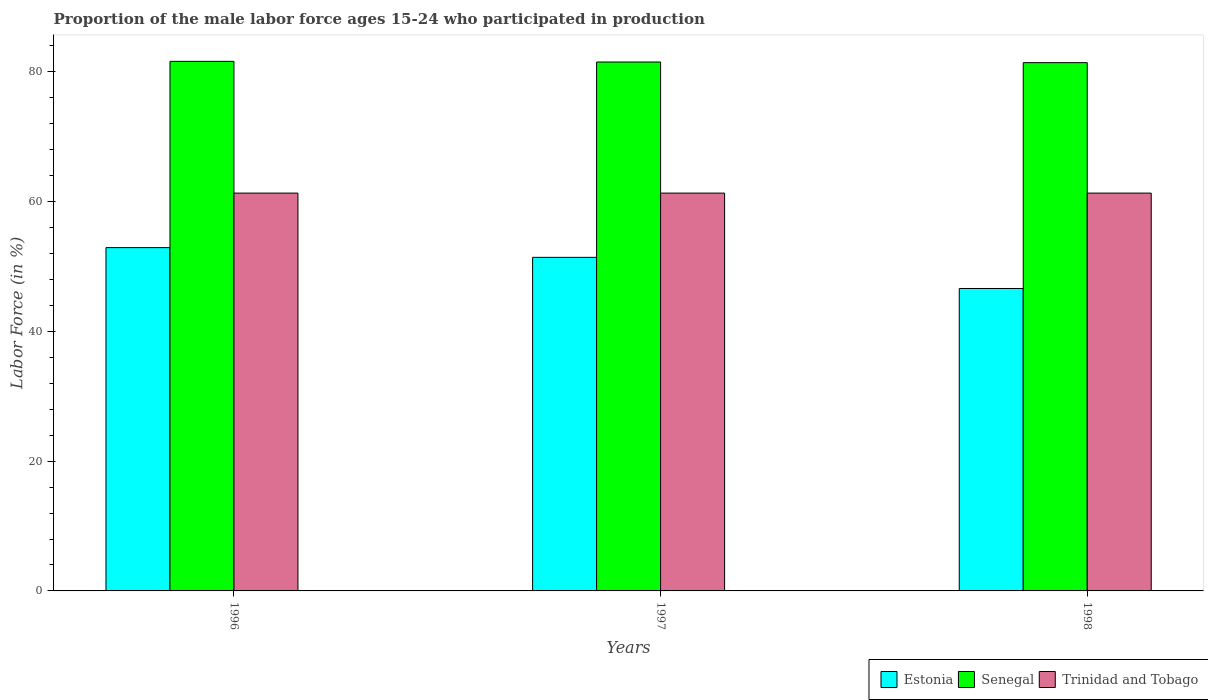How many different coloured bars are there?
Keep it short and to the point. 3. How many groups of bars are there?
Offer a terse response. 3. Are the number of bars on each tick of the X-axis equal?
Your answer should be compact. Yes. How many bars are there on the 3rd tick from the right?
Provide a short and direct response. 3. What is the label of the 1st group of bars from the left?
Your answer should be very brief. 1996. In how many cases, is the number of bars for a given year not equal to the number of legend labels?
Keep it short and to the point. 0. What is the proportion of the male labor force who participated in production in Senegal in 1998?
Keep it short and to the point. 81.4. Across all years, what is the maximum proportion of the male labor force who participated in production in Estonia?
Your response must be concise. 52.9. Across all years, what is the minimum proportion of the male labor force who participated in production in Senegal?
Offer a very short reply. 81.4. In which year was the proportion of the male labor force who participated in production in Trinidad and Tobago maximum?
Keep it short and to the point. 1996. What is the total proportion of the male labor force who participated in production in Trinidad and Tobago in the graph?
Your answer should be compact. 183.9. What is the difference between the proportion of the male labor force who participated in production in Estonia in 1996 and that in 1997?
Keep it short and to the point. 1.5. What is the difference between the proportion of the male labor force who participated in production in Estonia in 1997 and the proportion of the male labor force who participated in production in Senegal in 1996?
Ensure brevity in your answer.  -30.2. What is the average proportion of the male labor force who participated in production in Estonia per year?
Give a very brief answer. 50.3. In the year 1998, what is the difference between the proportion of the male labor force who participated in production in Estonia and proportion of the male labor force who participated in production in Trinidad and Tobago?
Offer a very short reply. -14.7. What is the ratio of the proportion of the male labor force who participated in production in Senegal in 1996 to that in 1998?
Provide a short and direct response. 1. Is the proportion of the male labor force who participated in production in Trinidad and Tobago in 1996 less than that in 1997?
Make the answer very short. No. Is the difference between the proportion of the male labor force who participated in production in Estonia in 1997 and 1998 greater than the difference between the proportion of the male labor force who participated in production in Trinidad and Tobago in 1997 and 1998?
Your answer should be compact. Yes. What is the difference between the highest and the second highest proportion of the male labor force who participated in production in Estonia?
Ensure brevity in your answer.  1.5. What is the difference between the highest and the lowest proportion of the male labor force who participated in production in Trinidad and Tobago?
Provide a short and direct response. 0. In how many years, is the proportion of the male labor force who participated in production in Trinidad and Tobago greater than the average proportion of the male labor force who participated in production in Trinidad and Tobago taken over all years?
Your response must be concise. 0. What does the 1st bar from the left in 1996 represents?
Your response must be concise. Estonia. What does the 2nd bar from the right in 1996 represents?
Give a very brief answer. Senegal. How many bars are there?
Your answer should be very brief. 9. Are all the bars in the graph horizontal?
Your answer should be very brief. No. How many years are there in the graph?
Make the answer very short. 3. What is the difference between two consecutive major ticks on the Y-axis?
Provide a short and direct response. 20. Does the graph contain grids?
Ensure brevity in your answer.  No. Where does the legend appear in the graph?
Your answer should be very brief. Bottom right. How are the legend labels stacked?
Make the answer very short. Horizontal. What is the title of the graph?
Ensure brevity in your answer.  Proportion of the male labor force ages 15-24 who participated in production. Does "Malaysia" appear as one of the legend labels in the graph?
Offer a terse response. No. What is the label or title of the Y-axis?
Your answer should be very brief. Labor Force (in %). What is the Labor Force (in %) in Estonia in 1996?
Ensure brevity in your answer.  52.9. What is the Labor Force (in %) in Senegal in 1996?
Provide a succinct answer. 81.6. What is the Labor Force (in %) in Trinidad and Tobago in 1996?
Provide a succinct answer. 61.3. What is the Labor Force (in %) of Estonia in 1997?
Your answer should be compact. 51.4. What is the Labor Force (in %) of Senegal in 1997?
Provide a short and direct response. 81.5. What is the Labor Force (in %) in Trinidad and Tobago in 1997?
Keep it short and to the point. 61.3. What is the Labor Force (in %) in Estonia in 1998?
Your response must be concise. 46.6. What is the Labor Force (in %) of Senegal in 1998?
Offer a very short reply. 81.4. What is the Labor Force (in %) of Trinidad and Tobago in 1998?
Your answer should be compact. 61.3. Across all years, what is the maximum Labor Force (in %) in Estonia?
Make the answer very short. 52.9. Across all years, what is the maximum Labor Force (in %) of Senegal?
Offer a very short reply. 81.6. Across all years, what is the maximum Labor Force (in %) of Trinidad and Tobago?
Ensure brevity in your answer.  61.3. Across all years, what is the minimum Labor Force (in %) in Estonia?
Give a very brief answer. 46.6. Across all years, what is the minimum Labor Force (in %) of Senegal?
Give a very brief answer. 81.4. Across all years, what is the minimum Labor Force (in %) of Trinidad and Tobago?
Provide a succinct answer. 61.3. What is the total Labor Force (in %) of Estonia in the graph?
Ensure brevity in your answer.  150.9. What is the total Labor Force (in %) of Senegal in the graph?
Offer a terse response. 244.5. What is the total Labor Force (in %) in Trinidad and Tobago in the graph?
Give a very brief answer. 183.9. What is the difference between the Labor Force (in %) in Senegal in 1996 and that in 1997?
Provide a succinct answer. 0.1. What is the difference between the Labor Force (in %) in Senegal in 1996 and that in 1998?
Your response must be concise. 0.2. What is the difference between the Labor Force (in %) in Estonia in 1996 and the Labor Force (in %) in Senegal in 1997?
Provide a short and direct response. -28.6. What is the difference between the Labor Force (in %) of Estonia in 1996 and the Labor Force (in %) of Trinidad and Tobago in 1997?
Ensure brevity in your answer.  -8.4. What is the difference between the Labor Force (in %) of Senegal in 1996 and the Labor Force (in %) of Trinidad and Tobago in 1997?
Your answer should be compact. 20.3. What is the difference between the Labor Force (in %) in Estonia in 1996 and the Labor Force (in %) in Senegal in 1998?
Offer a terse response. -28.5. What is the difference between the Labor Force (in %) in Senegal in 1996 and the Labor Force (in %) in Trinidad and Tobago in 1998?
Provide a succinct answer. 20.3. What is the difference between the Labor Force (in %) of Estonia in 1997 and the Labor Force (in %) of Senegal in 1998?
Provide a succinct answer. -30. What is the difference between the Labor Force (in %) in Estonia in 1997 and the Labor Force (in %) in Trinidad and Tobago in 1998?
Keep it short and to the point. -9.9. What is the difference between the Labor Force (in %) in Senegal in 1997 and the Labor Force (in %) in Trinidad and Tobago in 1998?
Keep it short and to the point. 20.2. What is the average Labor Force (in %) in Estonia per year?
Your answer should be very brief. 50.3. What is the average Labor Force (in %) in Senegal per year?
Your answer should be compact. 81.5. What is the average Labor Force (in %) in Trinidad and Tobago per year?
Offer a very short reply. 61.3. In the year 1996, what is the difference between the Labor Force (in %) in Estonia and Labor Force (in %) in Senegal?
Offer a terse response. -28.7. In the year 1996, what is the difference between the Labor Force (in %) of Estonia and Labor Force (in %) of Trinidad and Tobago?
Provide a succinct answer. -8.4. In the year 1996, what is the difference between the Labor Force (in %) of Senegal and Labor Force (in %) of Trinidad and Tobago?
Your response must be concise. 20.3. In the year 1997, what is the difference between the Labor Force (in %) in Estonia and Labor Force (in %) in Senegal?
Make the answer very short. -30.1. In the year 1997, what is the difference between the Labor Force (in %) of Estonia and Labor Force (in %) of Trinidad and Tobago?
Keep it short and to the point. -9.9. In the year 1997, what is the difference between the Labor Force (in %) of Senegal and Labor Force (in %) of Trinidad and Tobago?
Keep it short and to the point. 20.2. In the year 1998, what is the difference between the Labor Force (in %) of Estonia and Labor Force (in %) of Senegal?
Provide a succinct answer. -34.8. In the year 1998, what is the difference between the Labor Force (in %) in Estonia and Labor Force (in %) in Trinidad and Tobago?
Your answer should be compact. -14.7. In the year 1998, what is the difference between the Labor Force (in %) of Senegal and Labor Force (in %) of Trinidad and Tobago?
Keep it short and to the point. 20.1. What is the ratio of the Labor Force (in %) of Estonia in 1996 to that in 1997?
Your answer should be very brief. 1.03. What is the ratio of the Labor Force (in %) of Estonia in 1996 to that in 1998?
Your answer should be very brief. 1.14. What is the ratio of the Labor Force (in %) of Estonia in 1997 to that in 1998?
Provide a short and direct response. 1.1. What is the ratio of the Labor Force (in %) in Senegal in 1997 to that in 1998?
Your answer should be very brief. 1. What is the ratio of the Labor Force (in %) of Trinidad and Tobago in 1997 to that in 1998?
Give a very brief answer. 1. What is the difference between the highest and the second highest Labor Force (in %) of Senegal?
Make the answer very short. 0.1. What is the difference between the highest and the lowest Labor Force (in %) in Trinidad and Tobago?
Provide a short and direct response. 0. 